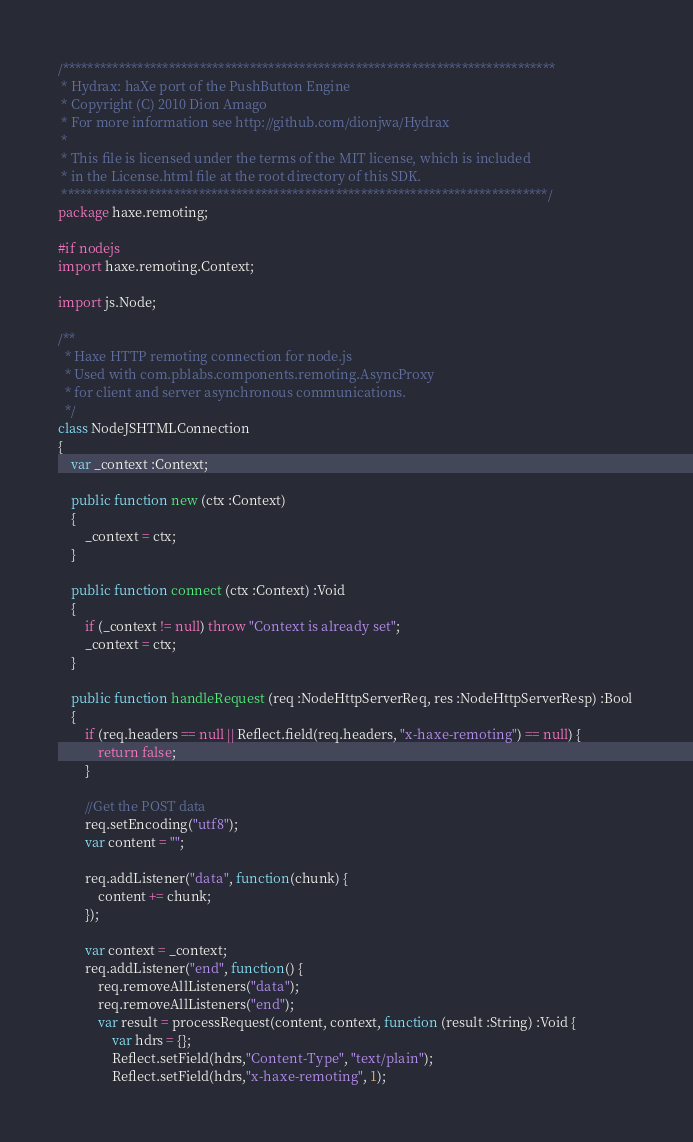Convert code to text. <code><loc_0><loc_0><loc_500><loc_500><_Haxe_>/*******************************************************************************
 * Hydrax: haXe port of the PushButton Engine
 * Copyright (C) 2010 Dion Amago
 * For more information see http://github.com/dionjwa/Hydrax
 *
 * This file is licensed under the terms of the MIT license, which is included
 * in the License.html file at the root directory of this SDK.
 ******************************************************************************/
package haxe.remoting;

#if nodejs
import haxe.remoting.Context;

import js.Node;

/**
  * Haxe HTTP remoting connection for node.js
  * Used with com.pblabs.components.remoting.AsyncProxy
  * for client and server asynchronous communications.
  */
class NodeJSHTMLConnection
{
	var _context :Context;
	
	public function new (ctx :Context)
	{
	    _context = ctx;
	}
	
	public function connect (ctx :Context) :Void
	{
		if (_context != null) throw "Context is already set";
		_context = ctx;
	}
	
	public function handleRequest (req :NodeHttpServerReq, res :NodeHttpServerResp) :Bool 
	{
		if (req.headers == null || Reflect.field(req.headers, "x-haxe-remoting") == null) {
			return false;
		}
		
		//Get the POST data
		req.setEncoding("utf8");
		var content = "";
		
		req.addListener("data", function(chunk) {
			content += chunk;
		});

		var context = _context;
		req.addListener("end", function() {
			req.removeAllListeners("data");
			req.removeAllListeners("end");
			var result = processRequest(content, context, function (result :String) :Void {
				var hdrs = {};
				Reflect.setField(hdrs,"Content-Type", "text/plain");
				Reflect.setField(hdrs,"x-haxe-remoting", 1);</code> 